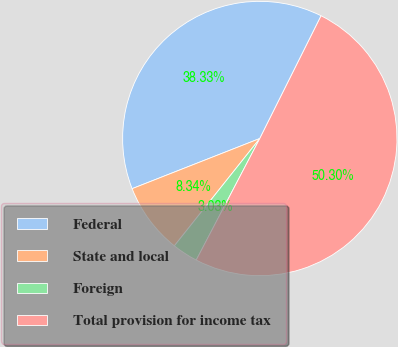Convert chart. <chart><loc_0><loc_0><loc_500><loc_500><pie_chart><fcel>Federal<fcel>State and local<fcel>Foreign<fcel>Total provision for income tax<nl><fcel>38.33%<fcel>8.34%<fcel>3.03%<fcel>50.29%<nl></chart> 